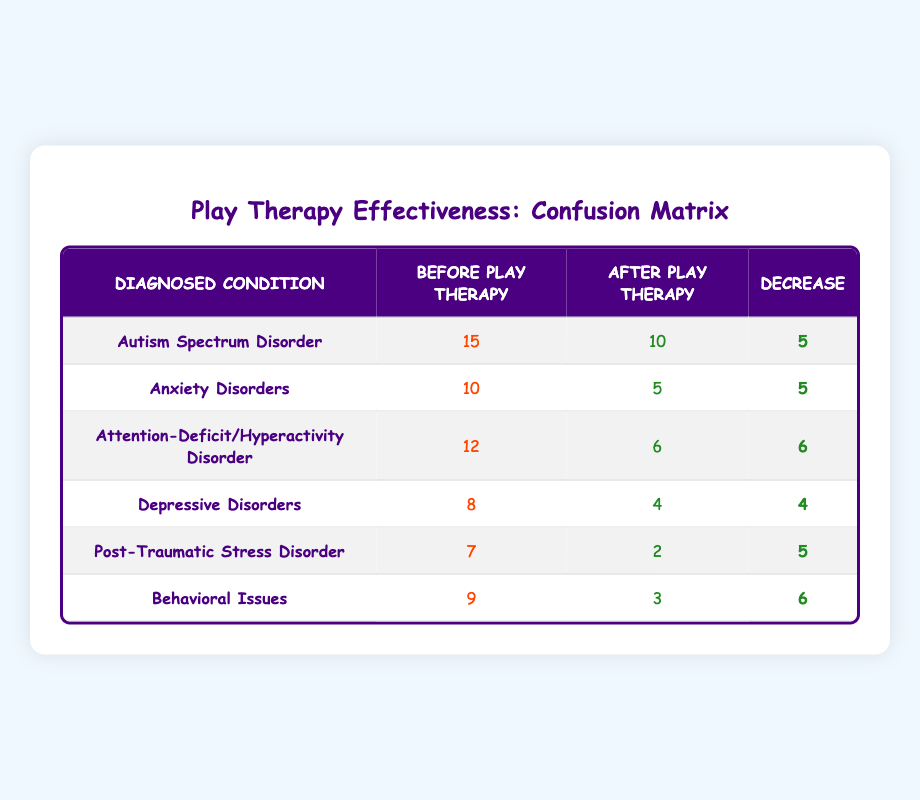What was the diagnosed condition with the highest decrease after play therapy? By examining the 'Decrease' values in the table, we can compare each condition. The 'Behavioral Issues' had a decrease of 6, which is the highest among all conditions listed.
Answer: Behavioral Issues How many children were diagnosed with Attention-Deficit/Hyperactivity Disorder before play therapy? This can be directly retrieved from the 'Before Play Therapy' column in the table, which shows the value for Attention-Deficit/Hyperactivity Disorder is 12.
Answer: 12 Was there any diagnosed condition that showed no decrease after play therapy? By looking at the 'Decrease' column, we can see all values are greater than 0, meaning that every condition had a decrease.
Answer: No What is the total number of children diagnosed with anxiety disorders before and after play therapy? To answer this, we add the values in both 'Before Play Therapy' and 'After Play Therapy' columns for Anxiety Disorders: 10 (before) + 5 (after) = 15.
Answer: 15 What was the greatest number of children diagnosed with a disorder before play therapy and which disorder was it? In the 'Before Play Therapy' column, Autism Spectrum Disorder has the highest count, with 15 children diagnosed.
Answer: 15 Autism Spectrum Disorder What is the average decrease in the number of children diagnosed with disorders after play therapy? First, we sum the decrease values: 5 + 5 + 6 + 4 + 5 + 6 = 31. Then, we divide by the number of conditions (6), leading to an average decrease of 31 / 6 = 5.17 (rounded).
Answer: 5.17 Which condition had the second lowest number of diagnoses after play therapy? Looking at the 'After Play Therapy' column, we see 'Post-Traumatic Stress Disorder' with 2, which is the second lowest after 'Depressive Disorders' with 4.
Answer: Post-Traumatic Stress Disorder Is the decrease in diagnosed Autism Spectrum Disorder higher or lower than the decrease in Depressive Disorders? The decrease for Autism Spectrum Disorder is 5 while for Depressive Disorders it is 4. Since 5 is greater than 4, the decrease in Autism Spectrum Disorder is higher.
Answer: Higher How many children were diagnosed with Depressive Disorders after play therapy? This value can be directly taken from the table; under the 'After Play Therapy' column for Depressive Disorders, the number is 4.
Answer: 4 